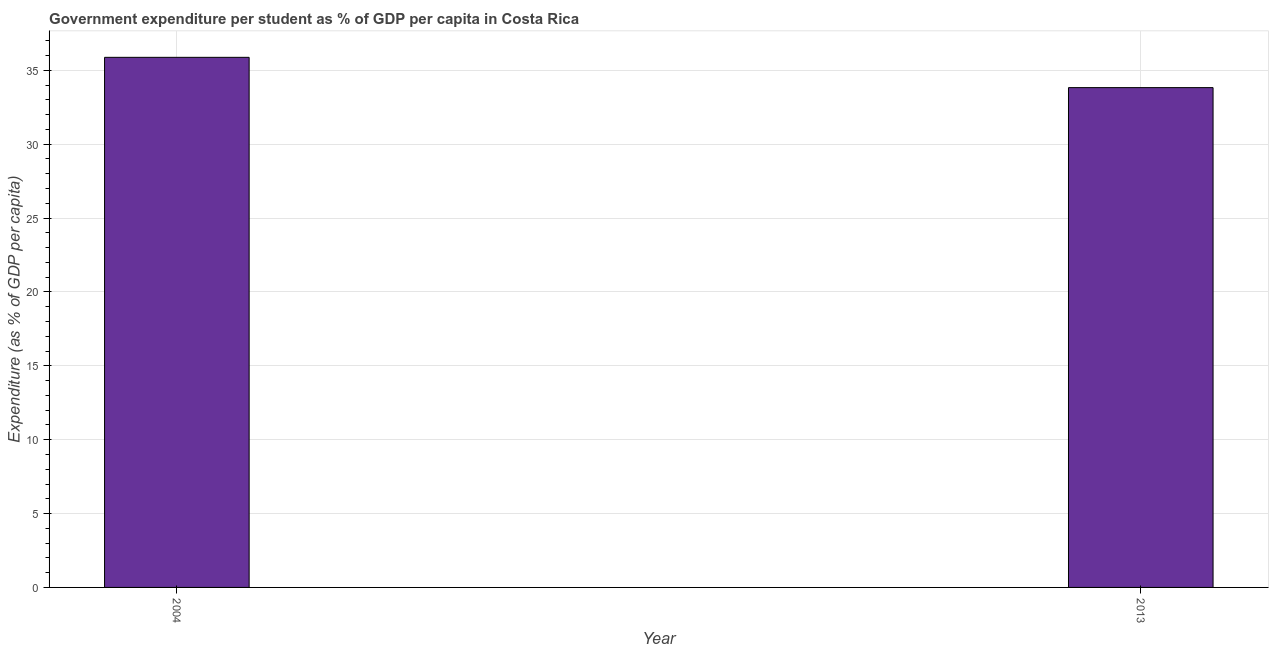Does the graph contain any zero values?
Give a very brief answer. No. Does the graph contain grids?
Give a very brief answer. Yes. What is the title of the graph?
Your answer should be very brief. Government expenditure per student as % of GDP per capita in Costa Rica. What is the label or title of the Y-axis?
Your response must be concise. Expenditure (as % of GDP per capita). What is the government expenditure per student in 2013?
Ensure brevity in your answer.  33.83. Across all years, what is the maximum government expenditure per student?
Keep it short and to the point. 35.88. Across all years, what is the minimum government expenditure per student?
Make the answer very short. 33.83. In which year was the government expenditure per student maximum?
Your answer should be compact. 2004. What is the sum of the government expenditure per student?
Make the answer very short. 69.71. What is the difference between the government expenditure per student in 2004 and 2013?
Provide a short and direct response. 2.05. What is the average government expenditure per student per year?
Provide a short and direct response. 34.85. What is the median government expenditure per student?
Offer a terse response. 34.85. In how many years, is the government expenditure per student greater than 26 %?
Your answer should be compact. 2. Do a majority of the years between 2004 and 2013 (inclusive) have government expenditure per student greater than 28 %?
Provide a short and direct response. Yes. What is the ratio of the government expenditure per student in 2004 to that in 2013?
Your answer should be compact. 1.06. Is the government expenditure per student in 2004 less than that in 2013?
Offer a terse response. No. How many bars are there?
Your answer should be very brief. 2. Are the values on the major ticks of Y-axis written in scientific E-notation?
Ensure brevity in your answer.  No. What is the Expenditure (as % of GDP per capita) of 2004?
Offer a terse response. 35.88. What is the Expenditure (as % of GDP per capita) in 2013?
Make the answer very short. 33.83. What is the difference between the Expenditure (as % of GDP per capita) in 2004 and 2013?
Keep it short and to the point. 2.05. What is the ratio of the Expenditure (as % of GDP per capita) in 2004 to that in 2013?
Your answer should be very brief. 1.06. 